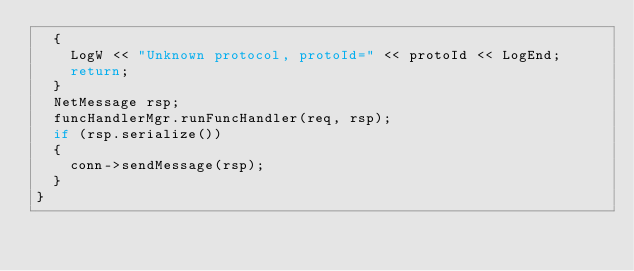Convert code to text. <code><loc_0><loc_0><loc_500><loc_500><_C++_>	{
		LogW << "Unknown protocol, protoId=" << protoId << LogEnd;
		return;
	}
	NetMessage rsp;
	funcHandlerMgr.runFuncHandler(req, rsp);
	if (rsp.serialize())
	{
		conn->sendMessage(rsp);
	}	
}

</code> 